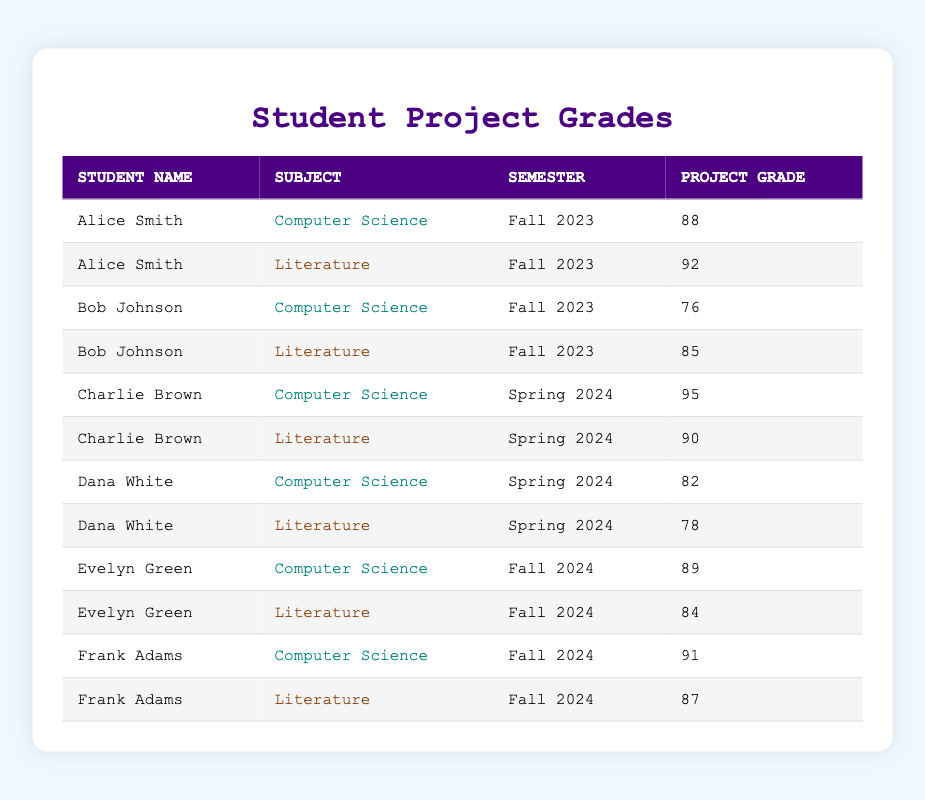What is Alice Smith's project grade in Literature for Fall 2023? Alice Smith's row for Literature in Fall 2023 shows a project grade of 92.
Answer: 92 What subject did Bob Johnson get a lower grade in for Fall 2023? Comparing Bob Johnson's grades, he received 76 in Computer Science and 85 in Literature, so he did worse in Computer Science.
Answer: Computer Science What is the highest project grade listed in the table? The highest project grade is found in Charlie Brown's row for Computer Science in Spring 2024, which is 95.
Answer: 95 How many students received a project grade of 80 or higher in Literature? The grades for Literature are 92, 85, 90, 78, 84, and 87. Counting those 92, 85, 90, 84, and 87 exceeds 80, totaling 5 students.
Answer: 5 What is the average project grade for Computer Science across all semesters? The project grades for Computer Science are 88, 76, 95, 82, 89, and 91. Sum these grades (88 + 76 + 95 + 82 + 89 + 91 = 521). There are 6 grades, so the average is 521 / 6 = 86.83.
Answer: 86.83 Did Evelyn Green perform better in Computer Science or Literature in Fall 2024? Evelyn Green received a project grade of 89 in Computer Science and 84 in Literature, indicating that she performed better in Computer Science.
Answer: Yes What is the difference between Charlie Brown's grades in Computer Science and Literature for Spring 2024? Charlie Brown's grades are 95 in Computer Science and 90 in Literature, giving a difference of 95 - 90 = 5.
Answer: 5 Which student received the lowest project grade across all subjects and semesters? The lowest project grade is from Bob Johnson in Computer Science for Fall 2023, which is 76.
Answer: 76 How many total project grades are listed for Spring 2024? The table shows 4 entries for Spring 2024: Charlie Brown (both subjects) and Dana White (both subjects).
Answer: 4 What is the total project grade earned by Frank Adams across both subjects? Frank Adams has grades of 91 in Computer Science and 87 in Literature. Summing these gives 91 + 87 = 178.
Answer: 178 What percentage of total project grades is represented by Alice Smith's grades in Fall 2023? Alice Smith’s grades are 88 and 92, summing to 180. The total of all project grades is 88 + 76 + 92 + 85 + 95 + 90 + 82 + 78 + 89 + 84 + 91 + 87 = 1026. Hence, the percentage of Alice's grades is (180 / 1026) * 100 ≈ 17.54%.
Answer: 17.54% 